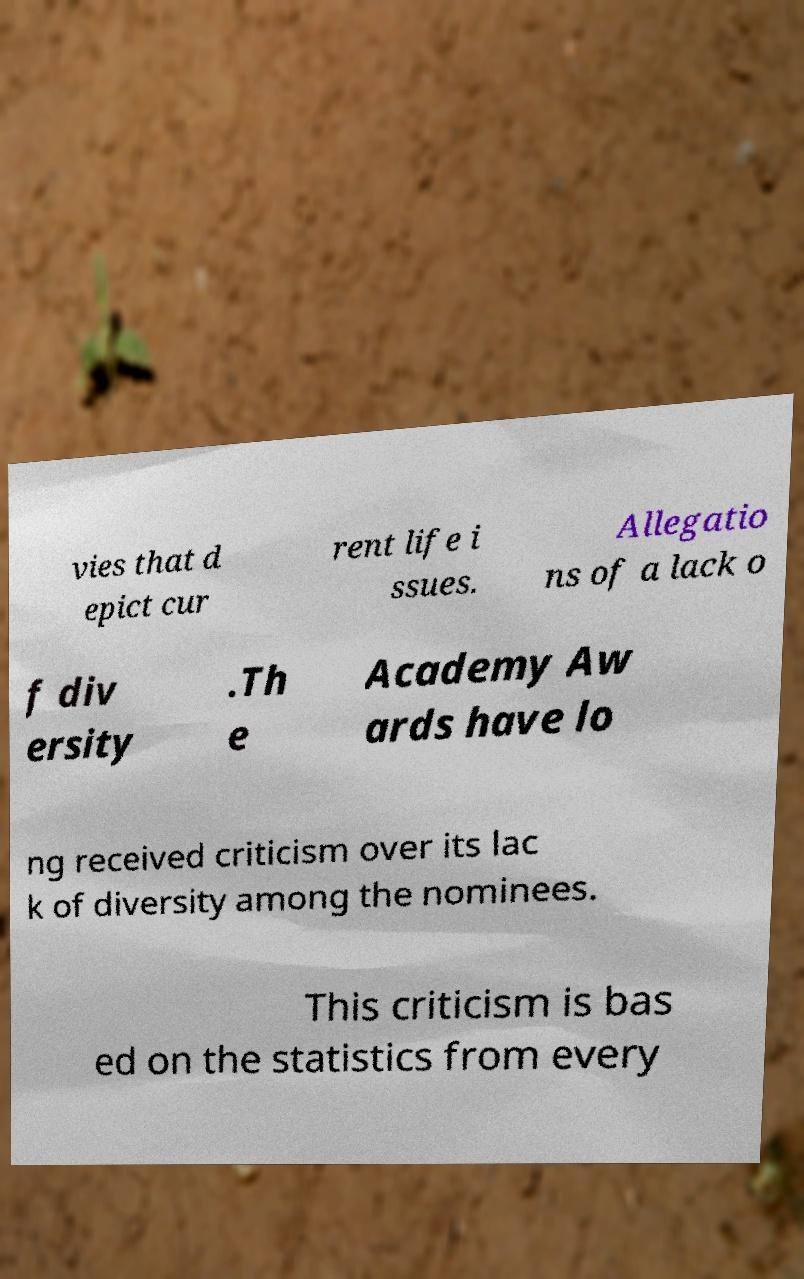There's text embedded in this image that I need extracted. Can you transcribe it verbatim? vies that d epict cur rent life i ssues. Allegatio ns of a lack o f div ersity .Th e Academy Aw ards have lo ng received criticism over its lac k of diversity among the nominees. This criticism is bas ed on the statistics from every 